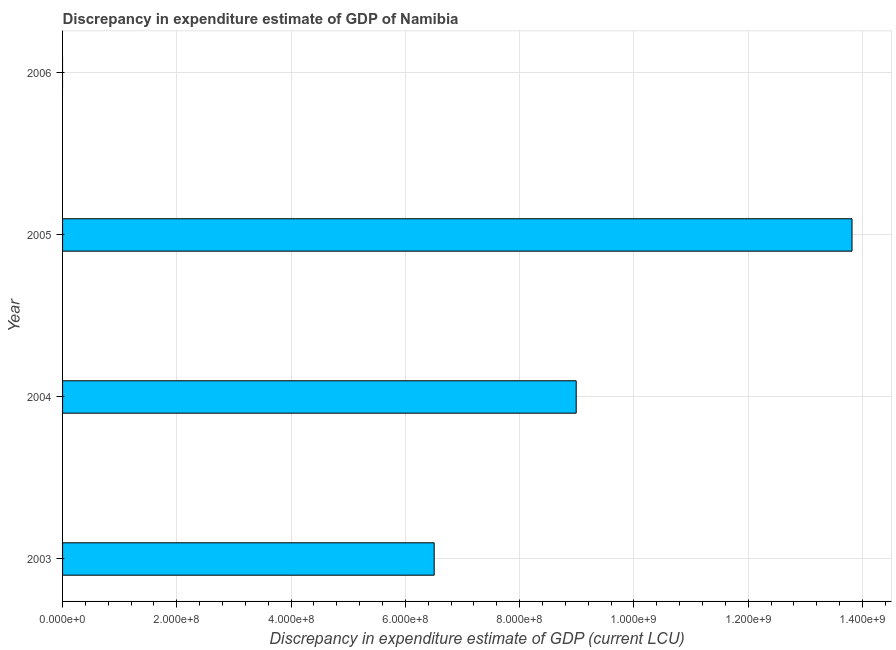Does the graph contain any zero values?
Provide a short and direct response. Yes. Does the graph contain grids?
Give a very brief answer. Yes. What is the title of the graph?
Make the answer very short. Discrepancy in expenditure estimate of GDP of Namibia. What is the label or title of the X-axis?
Offer a terse response. Discrepancy in expenditure estimate of GDP (current LCU). What is the label or title of the Y-axis?
Offer a very short reply. Year. What is the discrepancy in expenditure estimate of gdp in 2005?
Provide a succinct answer. 1.38e+09. Across all years, what is the maximum discrepancy in expenditure estimate of gdp?
Your response must be concise. 1.38e+09. In which year was the discrepancy in expenditure estimate of gdp maximum?
Ensure brevity in your answer.  2005. What is the sum of the discrepancy in expenditure estimate of gdp?
Your response must be concise. 2.93e+09. What is the difference between the discrepancy in expenditure estimate of gdp in 2004 and 2005?
Your answer should be compact. -4.83e+08. What is the average discrepancy in expenditure estimate of gdp per year?
Provide a short and direct response. 7.33e+08. What is the median discrepancy in expenditure estimate of gdp?
Offer a very short reply. 7.75e+08. In how many years, is the discrepancy in expenditure estimate of gdp greater than 1320000000 LCU?
Keep it short and to the point. 1. What is the ratio of the discrepancy in expenditure estimate of gdp in 2003 to that in 2005?
Your response must be concise. 0.47. What is the difference between the highest and the second highest discrepancy in expenditure estimate of gdp?
Offer a very short reply. 4.83e+08. What is the difference between the highest and the lowest discrepancy in expenditure estimate of gdp?
Provide a succinct answer. 1.38e+09. In how many years, is the discrepancy in expenditure estimate of gdp greater than the average discrepancy in expenditure estimate of gdp taken over all years?
Keep it short and to the point. 2. Are the values on the major ticks of X-axis written in scientific E-notation?
Your answer should be very brief. Yes. What is the Discrepancy in expenditure estimate of GDP (current LCU) in 2003?
Provide a short and direct response. 6.50e+08. What is the Discrepancy in expenditure estimate of GDP (current LCU) in 2004?
Give a very brief answer. 8.99e+08. What is the Discrepancy in expenditure estimate of GDP (current LCU) of 2005?
Offer a very short reply. 1.38e+09. What is the difference between the Discrepancy in expenditure estimate of GDP (current LCU) in 2003 and 2004?
Give a very brief answer. -2.49e+08. What is the difference between the Discrepancy in expenditure estimate of GDP (current LCU) in 2003 and 2005?
Make the answer very short. -7.31e+08. What is the difference between the Discrepancy in expenditure estimate of GDP (current LCU) in 2004 and 2005?
Make the answer very short. -4.83e+08. What is the ratio of the Discrepancy in expenditure estimate of GDP (current LCU) in 2003 to that in 2004?
Keep it short and to the point. 0.72. What is the ratio of the Discrepancy in expenditure estimate of GDP (current LCU) in 2003 to that in 2005?
Offer a very short reply. 0.47. What is the ratio of the Discrepancy in expenditure estimate of GDP (current LCU) in 2004 to that in 2005?
Offer a very short reply. 0.65. 